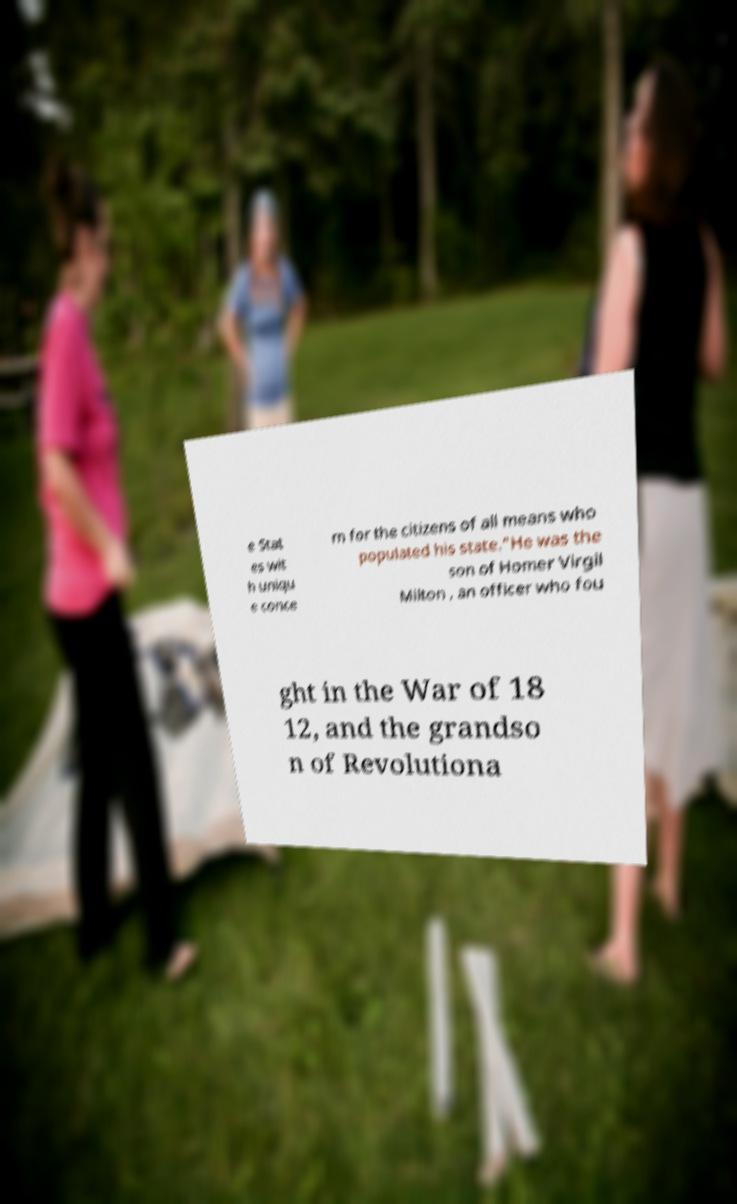What messages or text are displayed in this image? I need them in a readable, typed format. e Stat es wit h uniqu e conce rn for the citizens of all means who populated his state."He was the son of Homer Virgil Milton , an officer who fou ght in the War of 18 12, and the grandso n of Revolutiona 